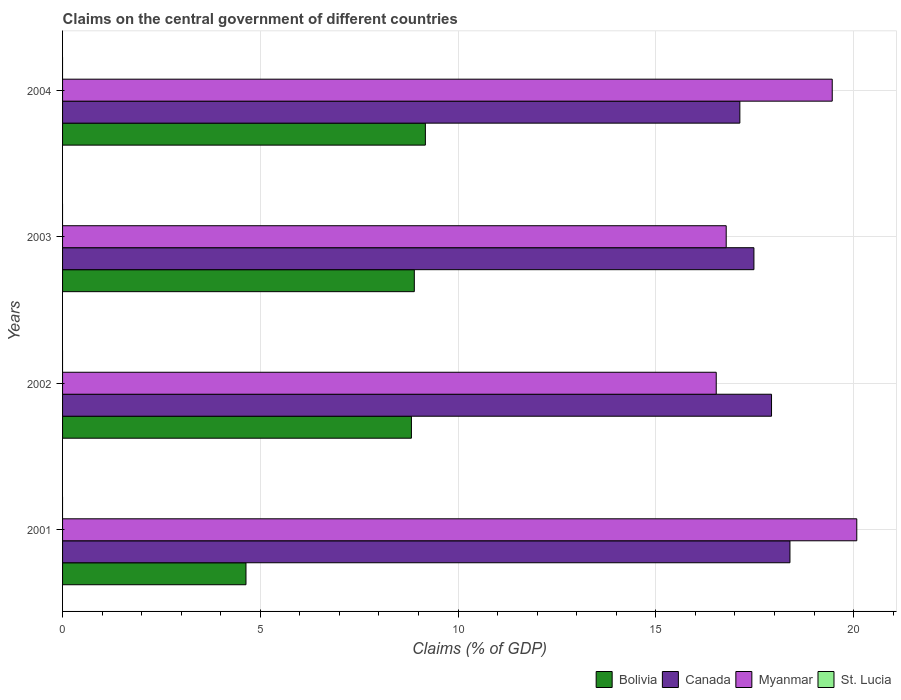Are the number of bars per tick equal to the number of legend labels?
Offer a very short reply. No. Are the number of bars on each tick of the Y-axis equal?
Provide a succinct answer. Yes. How many bars are there on the 1st tick from the bottom?
Your answer should be compact. 3. What is the label of the 1st group of bars from the top?
Your response must be concise. 2004. Across all years, what is the maximum percentage of GDP claimed on the central government in Canada?
Ensure brevity in your answer.  18.39. Across all years, what is the minimum percentage of GDP claimed on the central government in Myanmar?
Keep it short and to the point. 16.53. What is the difference between the percentage of GDP claimed on the central government in Myanmar in 2001 and that in 2003?
Your response must be concise. 3.3. What is the difference between the percentage of GDP claimed on the central government in Canada in 2004 and the percentage of GDP claimed on the central government in Myanmar in 2003?
Make the answer very short. 0.35. What is the average percentage of GDP claimed on the central government in Canada per year?
Offer a very short reply. 17.73. In the year 2001, what is the difference between the percentage of GDP claimed on the central government in Canada and percentage of GDP claimed on the central government in Bolivia?
Offer a terse response. 13.75. In how many years, is the percentage of GDP claimed on the central government in Bolivia greater than 13 %?
Your response must be concise. 0. What is the ratio of the percentage of GDP claimed on the central government in Bolivia in 2002 to that in 2003?
Keep it short and to the point. 0.99. Is the difference between the percentage of GDP claimed on the central government in Canada in 2001 and 2002 greater than the difference between the percentage of GDP claimed on the central government in Bolivia in 2001 and 2002?
Keep it short and to the point. Yes. What is the difference between the highest and the second highest percentage of GDP claimed on the central government in Canada?
Provide a short and direct response. 0.47. What is the difference between the highest and the lowest percentage of GDP claimed on the central government in Myanmar?
Your answer should be very brief. 3.55. In how many years, is the percentage of GDP claimed on the central government in Bolivia greater than the average percentage of GDP claimed on the central government in Bolivia taken over all years?
Keep it short and to the point. 3. Is it the case that in every year, the sum of the percentage of GDP claimed on the central government in Bolivia and percentage of GDP claimed on the central government in Canada is greater than the sum of percentage of GDP claimed on the central government in St. Lucia and percentage of GDP claimed on the central government in Myanmar?
Provide a short and direct response. Yes. Is it the case that in every year, the sum of the percentage of GDP claimed on the central government in Canada and percentage of GDP claimed on the central government in Bolivia is greater than the percentage of GDP claimed on the central government in St. Lucia?
Provide a succinct answer. Yes. How many bars are there?
Offer a terse response. 12. How many years are there in the graph?
Provide a short and direct response. 4. What is the difference between two consecutive major ticks on the X-axis?
Provide a succinct answer. 5. Are the values on the major ticks of X-axis written in scientific E-notation?
Make the answer very short. No. How many legend labels are there?
Your answer should be compact. 4. How are the legend labels stacked?
Your answer should be very brief. Horizontal. What is the title of the graph?
Your answer should be compact. Claims on the central government of different countries. Does "Hungary" appear as one of the legend labels in the graph?
Provide a succinct answer. No. What is the label or title of the X-axis?
Offer a terse response. Claims (% of GDP). What is the Claims (% of GDP) in Bolivia in 2001?
Keep it short and to the point. 4.64. What is the Claims (% of GDP) of Canada in 2001?
Provide a succinct answer. 18.39. What is the Claims (% of GDP) of Myanmar in 2001?
Offer a very short reply. 20.08. What is the Claims (% of GDP) in Bolivia in 2002?
Your answer should be compact. 8.82. What is the Claims (% of GDP) of Canada in 2002?
Ensure brevity in your answer.  17.93. What is the Claims (% of GDP) in Myanmar in 2002?
Offer a terse response. 16.53. What is the Claims (% of GDP) of St. Lucia in 2002?
Ensure brevity in your answer.  0. What is the Claims (% of GDP) of Bolivia in 2003?
Your response must be concise. 8.89. What is the Claims (% of GDP) of Canada in 2003?
Give a very brief answer. 17.48. What is the Claims (% of GDP) of Myanmar in 2003?
Keep it short and to the point. 16.78. What is the Claims (% of GDP) in St. Lucia in 2003?
Keep it short and to the point. 0. What is the Claims (% of GDP) in Bolivia in 2004?
Provide a succinct answer. 9.17. What is the Claims (% of GDP) of Canada in 2004?
Offer a very short reply. 17.13. What is the Claims (% of GDP) in Myanmar in 2004?
Your response must be concise. 19.46. Across all years, what is the maximum Claims (% of GDP) in Bolivia?
Your response must be concise. 9.17. Across all years, what is the maximum Claims (% of GDP) of Canada?
Give a very brief answer. 18.39. Across all years, what is the maximum Claims (% of GDP) in Myanmar?
Provide a succinct answer. 20.08. Across all years, what is the minimum Claims (% of GDP) in Bolivia?
Provide a succinct answer. 4.64. Across all years, what is the minimum Claims (% of GDP) in Canada?
Keep it short and to the point. 17.13. Across all years, what is the minimum Claims (% of GDP) of Myanmar?
Your response must be concise. 16.53. What is the total Claims (% of GDP) of Bolivia in the graph?
Provide a short and direct response. 31.53. What is the total Claims (% of GDP) of Canada in the graph?
Ensure brevity in your answer.  70.92. What is the total Claims (% of GDP) in Myanmar in the graph?
Offer a very short reply. 72.85. What is the total Claims (% of GDP) in St. Lucia in the graph?
Ensure brevity in your answer.  0. What is the difference between the Claims (% of GDP) of Bolivia in 2001 and that in 2002?
Provide a succinct answer. -4.18. What is the difference between the Claims (% of GDP) in Canada in 2001 and that in 2002?
Offer a very short reply. 0.47. What is the difference between the Claims (% of GDP) in Myanmar in 2001 and that in 2002?
Keep it short and to the point. 3.55. What is the difference between the Claims (% of GDP) in Bolivia in 2001 and that in 2003?
Ensure brevity in your answer.  -4.26. What is the difference between the Claims (% of GDP) in Canada in 2001 and that in 2003?
Ensure brevity in your answer.  0.91. What is the difference between the Claims (% of GDP) of Myanmar in 2001 and that in 2003?
Ensure brevity in your answer.  3.3. What is the difference between the Claims (% of GDP) in Bolivia in 2001 and that in 2004?
Provide a short and direct response. -4.54. What is the difference between the Claims (% of GDP) in Canada in 2001 and that in 2004?
Offer a very short reply. 1.27. What is the difference between the Claims (% of GDP) in Myanmar in 2001 and that in 2004?
Ensure brevity in your answer.  0.62. What is the difference between the Claims (% of GDP) in Bolivia in 2002 and that in 2003?
Offer a very short reply. -0.07. What is the difference between the Claims (% of GDP) of Canada in 2002 and that in 2003?
Provide a short and direct response. 0.45. What is the difference between the Claims (% of GDP) in Myanmar in 2002 and that in 2003?
Ensure brevity in your answer.  -0.25. What is the difference between the Claims (% of GDP) of Bolivia in 2002 and that in 2004?
Your answer should be very brief. -0.35. What is the difference between the Claims (% of GDP) of Canada in 2002 and that in 2004?
Offer a terse response. 0.8. What is the difference between the Claims (% of GDP) of Myanmar in 2002 and that in 2004?
Provide a succinct answer. -2.93. What is the difference between the Claims (% of GDP) of Bolivia in 2003 and that in 2004?
Keep it short and to the point. -0.28. What is the difference between the Claims (% of GDP) in Canada in 2003 and that in 2004?
Your response must be concise. 0.36. What is the difference between the Claims (% of GDP) of Myanmar in 2003 and that in 2004?
Give a very brief answer. -2.68. What is the difference between the Claims (% of GDP) in Bolivia in 2001 and the Claims (% of GDP) in Canada in 2002?
Your answer should be very brief. -13.29. What is the difference between the Claims (% of GDP) of Bolivia in 2001 and the Claims (% of GDP) of Myanmar in 2002?
Offer a very short reply. -11.89. What is the difference between the Claims (% of GDP) of Canada in 2001 and the Claims (% of GDP) of Myanmar in 2002?
Keep it short and to the point. 1.86. What is the difference between the Claims (% of GDP) in Bolivia in 2001 and the Claims (% of GDP) in Canada in 2003?
Provide a short and direct response. -12.84. What is the difference between the Claims (% of GDP) in Bolivia in 2001 and the Claims (% of GDP) in Myanmar in 2003?
Your answer should be compact. -12.14. What is the difference between the Claims (% of GDP) of Canada in 2001 and the Claims (% of GDP) of Myanmar in 2003?
Provide a succinct answer. 1.61. What is the difference between the Claims (% of GDP) in Bolivia in 2001 and the Claims (% of GDP) in Canada in 2004?
Offer a terse response. -12.49. What is the difference between the Claims (% of GDP) in Bolivia in 2001 and the Claims (% of GDP) in Myanmar in 2004?
Make the answer very short. -14.82. What is the difference between the Claims (% of GDP) in Canada in 2001 and the Claims (% of GDP) in Myanmar in 2004?
Give a very brief answer. -1.07. What is the difference between the Claims (% of GDP) in Bolivia in 2002 and the Claims (% of GDP) in Canada in 2003?
Your answer should be compact. -8.66. What is the difference between the Claims (% of GDP) in Bolivia in 2002 and the Claims (% of GDP) in Myanmar in 2003?
Your answer should be compact. -7.96. What is the difference between the Claims (% of GDP) in Canada in 2002 and the Claims (% of GDP) in Myanmar in 2003?
Ensure brevity in your answer.  1.15. What is the difference between the Claims (% of GDP) in Bolivia in 2002 and the Claims (% of GDP) in Canada in 2004?
Your response must be concise. -8.3. What is the difference between the Claims (% of GDP) in Bolivia in 2002 and the Claims (% of GDP) in Myanmar in 2004?
Give a very brief answer. -10.64. What is the difference between the Claims (% of GDP) of Canada in 2002 and the Claims (% of GDP) of Myanmar in 2004?
Provide a short and direct response. -1.53. What is the difference between the Claims (% of GDP) of Bolivia in 2003 and the Claims (% of GDP) of Canada in 2004?
Keep it short and to the point. -8.23. What is the difference between the Claims (% of GDP) in Bolivia in 2003 and the Claims (% of GDP) in Myanmar in 2004?
Ensure brevity in your answer.  -10.57. What is the difference between the Claims (% of GDP) of Canada in 2003 and the Claims (% of GDP) of Myanmar in 2004?
Keep it short and to the point. -1.98. What is the average Claims (% of GDP) in Bolivia per year?
Your answer should be compact. 7.88. What is the average Claims (% of GDP) in Canada per year?
Ensure brevity in your answer.  17.73. What is the average Claims (% of GDP) in Myanmar per year?
Offer a terse response. 18.21. In the year 2001, what is the difference between the Claims (% of GDP) of Bolivia and Claims (% of GDP) of Canada?
Offer a very short reply. -13.75. In the year 2001, what is the difference between the Claims (% of GDP) in Bolivia and Claims (% of GDP) in Myanmar?
Provide a succinct answer. -15.44. In the year 2001, what is the difference between the Claims (% of GDP) in Canada and Claims (% of GDP) in Myanmar?
Your answer should be very brief. -1.69. In the year 2002, what is the difference between the Claims (% of GDP) in Bolivia and Claims (% of GDP) in Canada?
Offer a very short reply. -9.11. In the year 2002, what is the difference between the Claims (% of GDP) of Bolivia and Claims (% of GDP) of Myanmar?
Your answer should be very brief. -7.71. In the year 2002, what is the difference between the Claims (% of GDP) in Canada and Claims (% of GDP) in Myanmar?
Offer a terse response. 1.4. In the year 2003, what is the difference between the Claims (% of GDP) in Bolivia and Claims (% of GDP) in Canada?
Provide a short and direct response. -8.59. In the year 2003, what is the difference between the Claims (% of GDP) of Bolivia and Claims (% of GDP) of Myanmar?
Make the answer very short. -7.89. In the year 2003, what is the difference between the Claims (% of GDP) of Canada and Claims (% of GDP) of Myanmar?
Provide a short and direct response. 0.7. In the year 2004, what is the difference between the Claims (% of GDP) of Bolivia and Claims (% of GDP) of Canada?
Offer a terse response. -7.95. In the year 2004, what is the difference between the Claims (% of GDP) in Bolivia and Claims (% of GDP) in Myanmar?
Your answer should be very brief. -10.29. In the year 2004, what is the difference between the Claims (% of GDP) in Canada and Claims (% of GDP) in Myanmar?
Your response must be concise. -2.34. What is the ratio of the Claims (% of GDP) of Bolivia in 2001 to that in 2002?
Your answer should be compact. 0.53. What is the ratio of the Claims (% of GDP) in Canada in 2001 to that in 2002?
Make the answer very short. 1.03. What is the ratio of the Claims (% of GDP) in Myanmar in 2001 to that in 2002?
Keep it short and to the point. 1.22. What is the ratio of the Claims (% of GDP) in Bolivia in 2001 to that in 2003?
Keep it short and to the point. 0.52. What is the ratio of the Claims (% of GDP) in Canada in 2001 to that in 2003?
Provide a short and direct response. 1.05. What is the ratio of the Claims (% of GDP) of Myanmar in 2001 to that in 2003?
Keep it short and to the point. 1.2. What is the ratio of the Claims (% of GDP) in Bolivia in 2001 to that in 2004?
Your response must be concise. 0.51. What is the ratio of the Claims (% of GDP) of Canada in 2001 to that in 2004?
Offer a terse response. 1.07. What is the ratio of the Claims (% of GDP) of Myanmar in 2001 to that in 2004?
Your response must be concise. 1.03. What is the ratio of the Claims (% of GDP) in Canada in 2002 to that in 2003?
Offer a very short reply. 1.03. What is the ratio of the Claims (% of GDP) of Bolivia in 2002 to that in 2004?
Offer a terse response. 0.96. What is the ratio of the Claims (% of GDP) of Canada in 2002 to that in 2004?
Ensure brevity in your answer.  1.05. What is the ratio of the Claims (% of GDP) in Myanmar in 2002 to that in 2004?
Provide a short and direct response. 0.85. What is the ratio of the Claims (% of GDP) of Bolivia in 2003 to that in 2004?
Make the answer very short. 0.97. What is the ratio of the Claims (% of GDP) of Canada in 2003 to that in 2004?
Make the answer very short. 1.02. What is the ratio of the Claims (% of GDP) in Myanmar in 2003 to that in 2004?
Your response must be concise. 0.86. What is the difference between the highest and the second highest Claims (% of GDP) of Bolivia?
Offer a terse response. 0.28. What is the difference between the highest and the second highest Claims (% of GDP) of Canada?
Provide a succinct answer. 0.47. What is the difference between the highest and the second highest Claims (% of GDP) of Myanmar?
Give a very brief answer. 0.62. What is the difference between the highest and the lowest Claims (% of GDP) of Bolivia?
Ensure brevity in your answer.  4.54. What is the difference between the highest and the lowest Claims (% of GDP) of Canada?
Provide a short and direct response. 1.27. What is the difference between the highest and the lowest Claims (% of GDP) of Myanmar?
Your answer should be very brief. 3.55. 